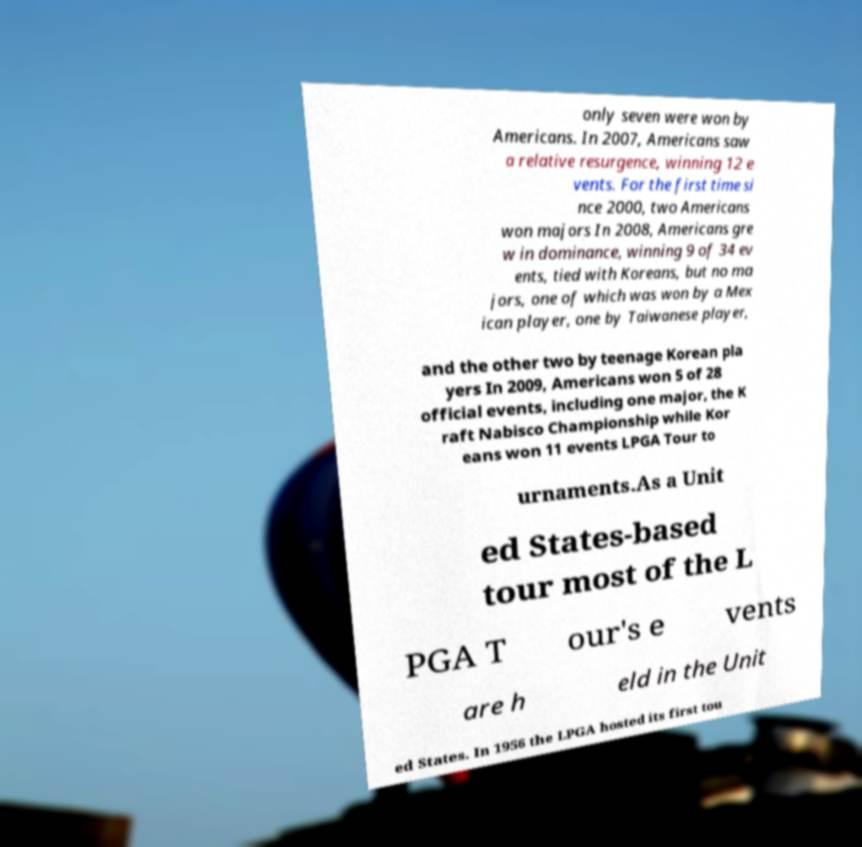For documentation purposes, I need the text within this image transcribed. Could you provide that? only seven were won by Americans. In 2007, Americans saw a relative resurgence, winning 12 e vents. For the first time si nce 2000, two Americans won majors In 2008, Americans gre w in dominance, winning 9 of 34 ev ents, tied with Koreans, but no ma jors, one of which was won by a Mex ican player, one by Taiwanese player, and the other two by teenage Korean pla yers In 2009, Americans won 5 of 28 official events, including one major, the K raft Nabisco Championship while Kor eans won 11 events LPGA Tour to urnaments.As a Unit ed States-based tour most of the L PGA T our's e vents are h eld in the Unit ed States. In 1956 the LPGA hosted its first tou 